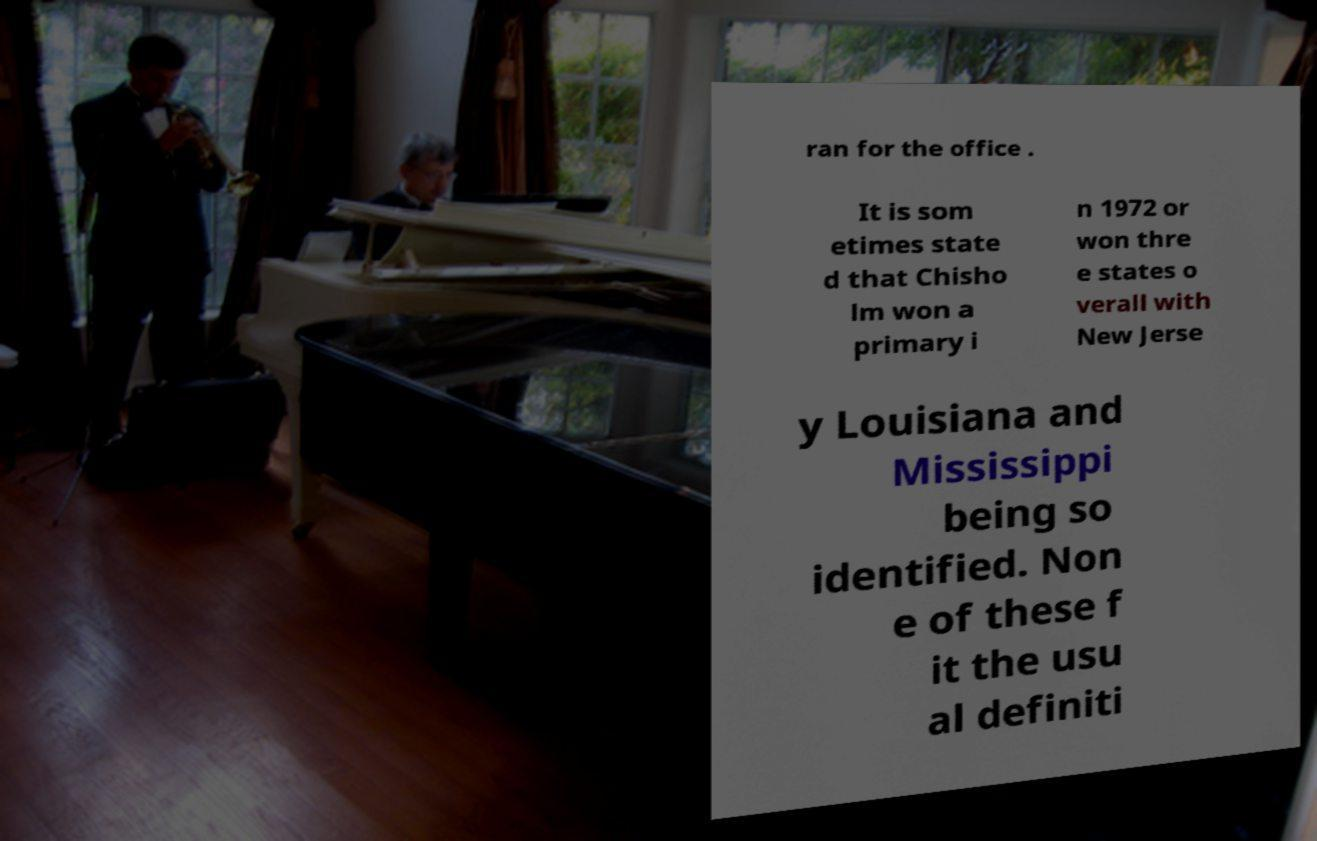What messages or text are displayed in this image? I need them in a readable, typed format. ran for the office . It is som etimes state d that Chisho lm won a primary i n 1972 or won thre e states o verall with New Jerse y Louisiana and Mississippi being so identified. Non e of these f it the usu al definiti 